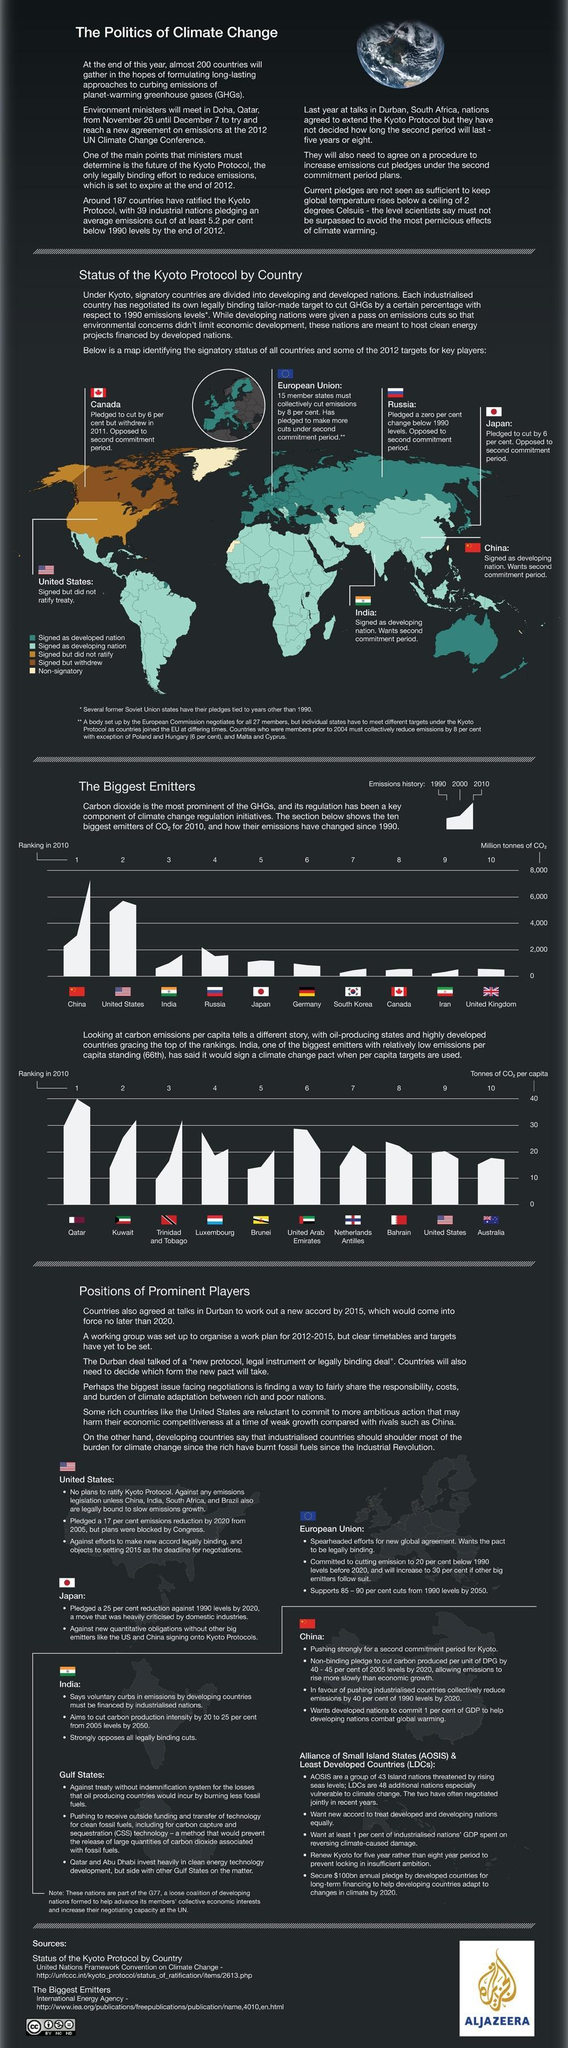Which Asian island country shown in the map is opposed to second commitment period?
Answer the question with a short phrase. Japan Which country signed the Kyoto Protocol but withdrew? Canada Where was the 2011 UN Climate Change Conference held? Durban, South Africa When was the 2012 UN Climate Change Conference held? from November 26 until December 7 As per the color code in the map, what is the signatory status of Australia? Signed as developed nation In the CO2 emission history of India, which year shows highest emissions? 2010 Which meeting was held at Doha from November 26 to December 7? UN Climate Change Conference In the CO2 emission history of the US, which year shows highest emissions? 2000 Which was the venue of the 2012 UN Climate Change Conference? Doha, Qatar In the CO2 emission history of Russia, which year shows highest emissions? 1990 